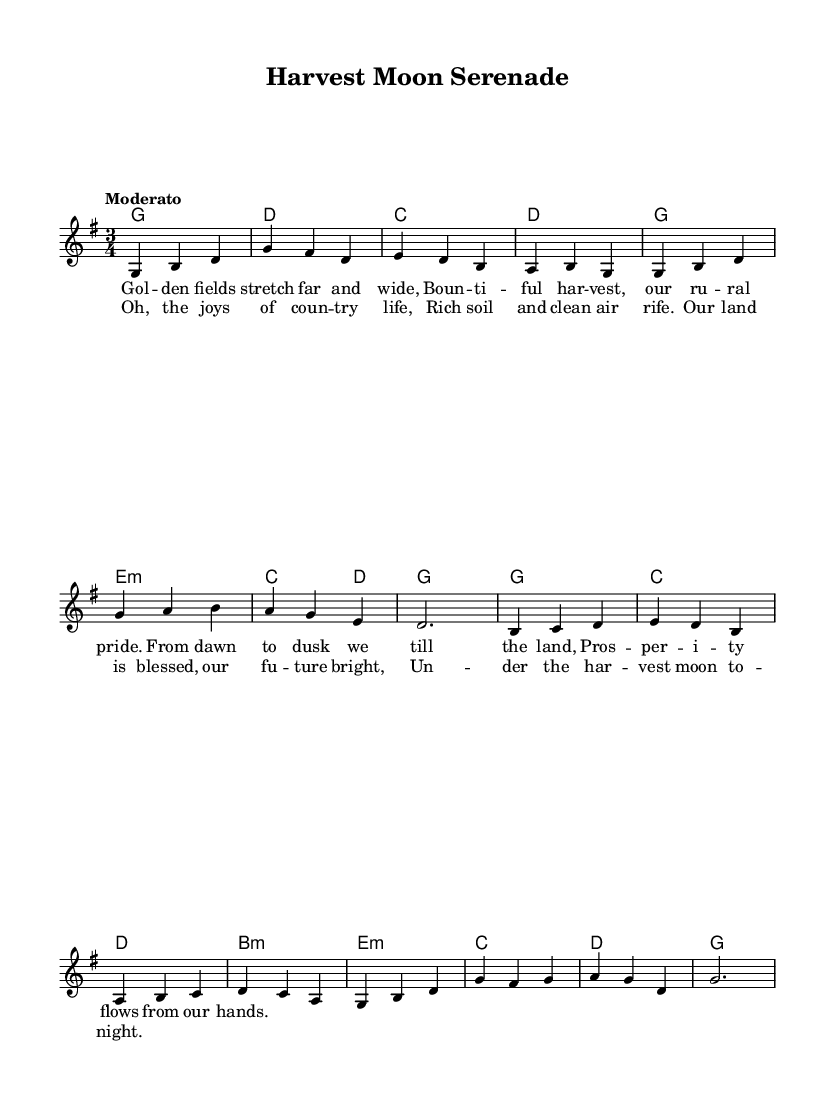What is the key signature of this music? The key signature is G major, indicated by the presence of one sharp (F sharp) in the key signature at the beginning of the sheet music.
Answer: G major What is the time signature of the piece? The time signature is 3/4, which consists of three beats per measure, as indicated next to the clef at the beginning of the music.
Answer: 3/4 What is the tempo marking of the music? The tempo marking is "Moderato," meaning a moderate pace, which provides an idea of how quickly the piece should be performed.
Answer: Moderato How many lines are in the verse? The verse contains four lines, as can be counted by looking at the lyrics provided above the melody in the music sheet.
Answer: Four What type of harmony accompanies the melody? The harmony consists mainly of major chords with some minor chords, which supports the melody and enhances the romantic characterization of the folk ballad.
Answer: Major and minor chords What themes are depicted in the lyrics? The lyrics depict themes of rural pride and agricultural prosperity, emphasizing the connection to land and the joy of country life as expressed through imagery of the harvest moon.
Answer: Rural pride and agricultural prosperity What is the structure of the piece regarding lyrics? The structure of the piece includes a verse followed by a chorus, where the verse tells a story and the chorus reinforces the main theme.
Answer: Verse and chorus 